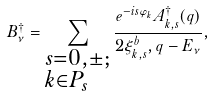<formula> <loc_0><loc_0><loc_500><loc_500>B _ { \nu } ^ { \dag } = \sum _ { \begin{subarray} { c } s = 0 , \pm ; \\ k \in P _ { s } \end{subarray} } \frac { e ^ { - i s \varphi _ { k } } A _ { k , s } ^ { \dag } ( q ) } { 2 \xi _ { k , s } ^ { b } , q - E _ { \nu } } ,</formula> 